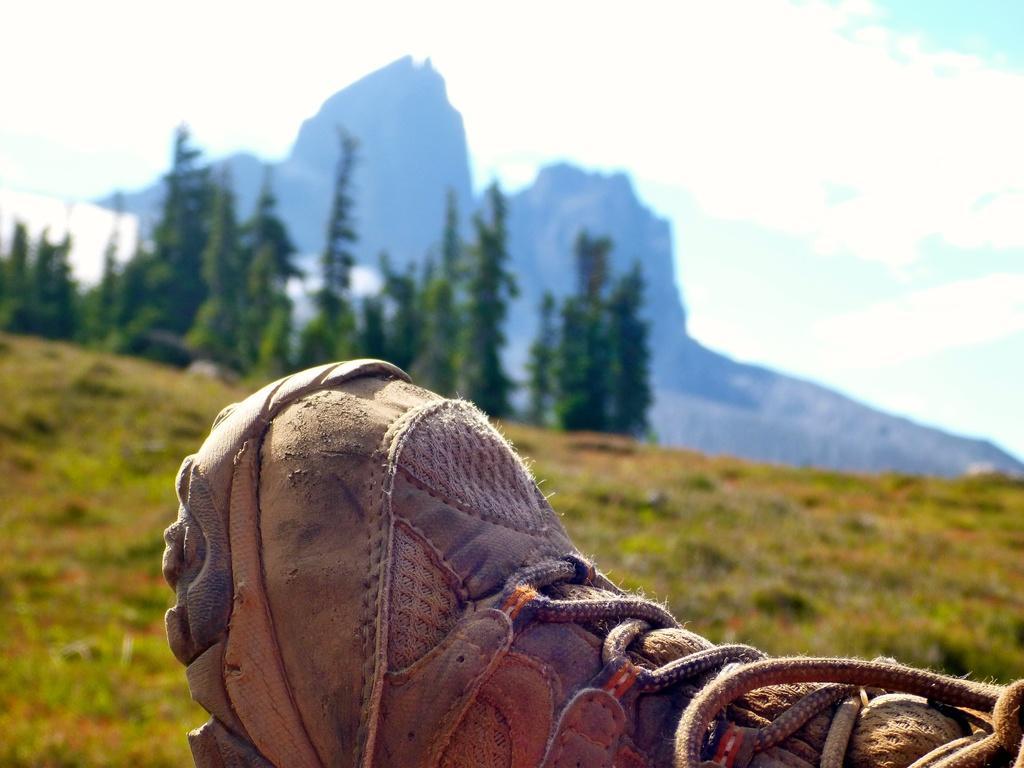In one or two sentences, can you explain what this image depicts? In the foreground of the image there is a shoe. In the background of the image there is a mountain. There are trees. There is grass. 